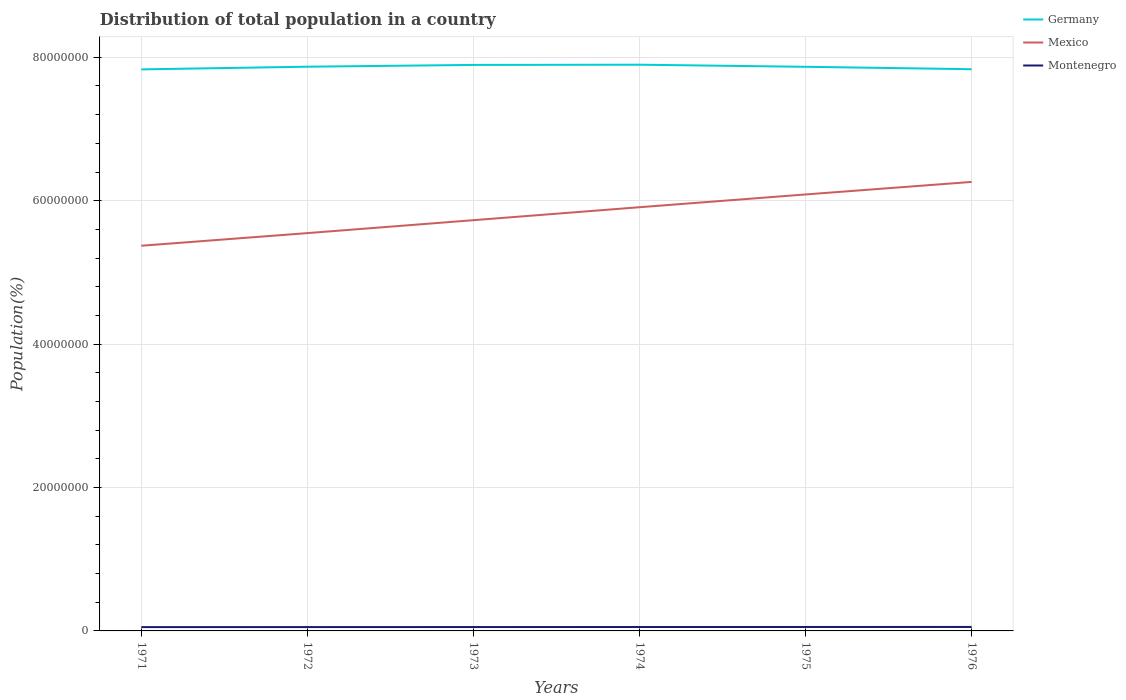How many different coloured lines are there?
Keep it short and to the point. 3. Does the line corresponding to Montenegro intersect with the line corresponding to Mexico?
Your answer should be compact. No. Is the number of lines equal to the number of legend labels?
Give a very brief answer. Yes. Across all years, what is the maximum population of in Mexico?
Offer a terse response. 5.37e+07. In which year was the population of in Germany maximum?
Keep it short and to the point. 1971. What is the total population of in Montenegro in the graph?
Give a very brief answer. -1.36e+04. What is the difference between the highest and the second highest population of in Mexico?
Your answer should be very brief. 8.90e+06. Are the values on the major ticks of Y-axis written in scientific E-notation?
Offer a very short reply. No. Where does the legend appear in the graph?
Offer a very short reply. Top right. How are the legend labels stacked?
Make the answer very short. Vertical. What is the title of the graph?
Your answer should be very brief. Distribution of total population in a country. Does "Bangladesh" appear as one of the legend labels in the graph?
Offer a very short reply. No. What is the label or title of the X-axis?
Your answer should be compact. Years. What is the label or title of the Y-axis?
Your response must be concise. Population(%). What is the Population(%) of Germany in 1971?
Offer a terse response. 7.83e+07. What is the Population(%) in Mexico in 1971?
Your answer should be compact. 5.37e+07. What is the Population(%) of Montenegro in 1971?
Offer a terse response. 5.31e+05. What is the Population(%) of Germany in 1972?
Provide a succinct answer. 7.87e+07. What is the Population(%) in Mexico in 1972?
Provide a succinct answer. 5.55e+07. What is the Population(%) in Montenegro in 1972?
Provide a short and direct response. 5.35e+05. What is the Population(%) in Germany in 1973?
Offer a very short reply. 7.89e+07. What is the Population(%) of Mexico in 1973?
Provide a short and direct response. 5.73e+07. What is the Population(%) in Montenegro in 1973?
Your answer should be compact. 5.40e+05. What is the Population(%) of Germany in 1974?
Make the answer very short. 7.90e+07. What is the Population(%) of Mexico in 1974?
Your answer should be compact. 5.91e+07. What is the Population(%) in Montenegro in 1974?
Offer a very short reply. 5.44e+05. What is the Population(%) of Germany in 1975?
Your answer should be very brief. 7.87e+07. What is the Population(%) of Mexico in 1975?
Your answer should be very brief. 6.09e+07. What is the Population(%) of Montenegro in 1975?
Provide a short and direct response. 5.49e+05. What is the Population(%) of Germany in 1976?
Keep it short and to the point. 7.83e+07. What is the Population(%) in Mexico in 1976?
Give a very brief answer. 6.26e+07. What is the Population(%) of Montenegro in 1976?
Provide a short and direct response. 5.54e+05. Across all years, what is the maximum Population(%) in Germany?
Provide a succinct answer. 7.90e+07. Across all years, what is the maximum Population(%) in Mexico?
Provide a short and direct response. 6.26e+07. Across all years, what is the maximum Population(%) in Montenegro?
Your answer should be compact. 5.54e+05. Across all years, what is the minimum Population(%) of Germany?
Make the answer very short. 7.83e+07. Across all years, what is the minimum Population(%) of Mexico?
Keep it short and to the point. 5.37e+07. Across all years, what is the minimum Population(%) of Montenegro?
Provide a succinct answer. 5.31e+05. What is the total Population(%) in Germany in the graph?
Offer a terse response. 4.72e+08. What is the total Population(%) in Mexico in the graph?
Ensure brevity in your answer.  3.49e+08. What is the total Population(%) in Montenegro in the graph?
Provide a succinct answer. 3.25e+06. What is the difference between the Population(%) of Germany in 1971 and that in 1972?
Make the answer very short. -3.76e+05. What is the difference between the Population(%) of Mexico in 1971 and that in 1972?
Keep it short and to the point. -1.76e+06. What is the difference between the Population(%) in Montenegro in 1971 and that in 1972?
Make the answer very short. -4492. What is the difference between the Population(%) of Germany in 1971 and that in 1973?
Your response must be concise. -6.24e+05. What is the difference between the Population(%) in Mexico in 1971 and that in 1973?
Offer a terse response. -3.56e+06. What is the difference between the Population(%) of Montenegro in 1971 and that in 1973?
Your answer should be compact. -8976. What is the difference between the Population(%) in Germany in 1971 and that in 1974?
Your response must be concise. -6.55e+05. What is the difference between the Population(%) in Mexico in 1971 and that in 1974?
Your answer should be very brief. -5.37e+06. What is the difference between the Population(%) of Montenegro in 1971 and that in 1974?
Offer a terse response. -1.36e+04. What is the difference between the Population(%) of Germany in 1971 and that in 1975?
Give a very brief answer. -3.61e+05. What is the difference between the Population(%) of Mexico in 1971 and that in 1975?
Provide a succinct answer. -7.15e+06. What is the difference between the Population(%) in Montenegro in 1971 and that in 1975?
Provide a short and direct response. -1.83e+04. What is the difference between the Population(%) in Germany in 1971 and that in 1976?
Ensure brevity in your answer.  -2.41e+04. What is the difference between the Population(%) in Mexico in 1971 and that in 1976?
Your response must be concise. -8.90e+06. What is the difference between the Population(%) of Montenegro in 1971 and that in 1976?
Offer a very short reply. -2.33e+04. What is the difference between the Population(%) in Germany in 1972 and that in 1973?
Provide a succinct answer. -2.48e+05. What is the difference between the Population(%) in Mexico in 1972 and that in 1973?
Provide a succinct answer. -1.80e+06. What is the difference between the Population(%) in Montenegro in 1972 and that in 1973?
Offer a very short reply. -4484. What is the difference between the Population(%) of Germany in 1972 and that in 1974?
Your answer should be very brief. -2.79e+05. What is the difference between the Population(%) in Mexico in 1972 and that in 1974?
Provide a short and direct response. -3.61e+06. What is the difference between the Population(%) in Montenegro in 1972 and that in 1974?
Make the answer very short. -9065. What is the difference between the Population(%) in Germany in 1972 and that in 1975?
Keep it short and to the point. 1.49e+04. What is the difference between the Population(%) of Mexico in 1972 and that in 1975?
Keep it short and to the point. -5.39e+06. What is the difference between the Population(%) of Montenegro in 1972 and that in 1975?
Your answer should be very brief. -1.38e+04. What is the difference between the Population(%) in Germany in 1972 and that in 1976?
Provide a short and direct response. 3.52e+05. What is the difference between the Population(%) of Mexico in 1972 and that in 1976?
Your answer should be very brief. -7.14e+06. What is the difference between the Population(%) of Montenegro in 1972 and that in 1976?
Offer a very short reply. -1.88e+04. What is the difference between the Population(%) of Germany in 1973 and that in 1974?
Keep it short and to the point. -3.08e+04. What is the difference between the Population(%) in Mexico in 1973 and that in 1974?
Make the answer very short. -1.81e+06. What is the difference between the Population(%) of Montenegro in 1973 and that in 1974?
Give a very brief answer. -4581. What is the difference between the Population(%) in Germany in 1973 and that in 1975?
Your answer should be compact. 2.63e+05. What is the difference between the Population(%) in Mexico in 1973 and that in 1975?
Your answer should be very brief. -3.59e+06. What is the difference between the Population(%) in Montenegro in 1973 and that in 1975?
Your answer should be compact. -9320. What is the difference between the Population(%) of Germany in 1973 and that in 1976?
Provide a short and direct response. 6.00e+05. What is the difference between the Population(%) in Mexico in 1973 and that in 1976?
Provide a succinct answer. -5.34e+06. What is the difference between the Population(%) of Montenegro in 1973 and that in 1976?
Your response must be concise. -1.43e+04. What is the difference between the Population(%) in Germany in 1974 and that in 1975?
Keep it short and to the point. 2.94e+05. What is the difference between the Population(%) of Mexico in 1974 and that in 1975?
Make the answer very short. -1.78e+06. What is the difference between the Population(%) of Montenegro in 1974 and that in 1975?
Your response must be concise. -4739. What is the difference between the Population(%) of Germany in 1974 and that in 1976?
Your response must be concise. 6.30e+05. What is the difference between the Population(%) of Mexico in 1974 and that in 1976?
Keep it short and to the point. -3.53e+06. What is the difference between the Population(%) in Montenegro in 1974 and that in 1976?
Provide a succinct answer. -9707. What is the difference between the Population(%) of Germany in 1975 and that in 1976?
Your response must be concise. 3.37e+05. What is the difference between the Population(%) of Mexico in 1975 and that in 1976?
Your answer should be compact. -1.75e+06. What is the difference between the Population(%) in Montenegro in 1975 and that in 1976?
Your answer should be compact. -4968. What is the difference between the Population(%) of Germany in 1971 and the Population(%) of Mexico in 1972?
Provide a short and direct response. 2.28e+07. What is the difference between the Population(%) in Germany in 1971 and the Population(%) in Montenegro in 1972?
Keep it short and to the point. 7.78e+07. What is the difference between the Population(%) in Mexico in 1971 and the Population(%) in Montenegro in 1972?
Give a very brief answer. 5.32e+07. What is the difference between the Population(%) of Germany in 1971 and the Population(%) of Mexico in 1973?
Make the answer very short. 2.10e+07. What is the difference between the Population(%) of Germany in 1971 and the Population(%) of Montenegro in 1973?
Make the answer very short. 7.78e+07. What is the difference between the Population(%) in Mexico in 1971 and the Population(%) in Montenegro in 1973?
Keep it short and to the point. 5.32e+07. What is the difference between the Population(%) of Germany in 1971 and the Population(%) of Mexico in 1974?
Make the answer very short. 1.92e+07. What is the difference between the Population(%) of Germany in 1971 and the Population(%) of Montenegro in 1974?
Offer a very short reply. 7.78e+07. What is the difference between the Population(%) in Mexico in 1971 and the Population(%) in Montenegro in 1974?
Your answer should be very brief. 5.32e+07. What is the difference between the Population(%) in Germany in 1971 and the Population(%) in Mexico in 1975?
Provide a succinct answer. 1.74e+07. What is the difference between the Population(%) in Germany in 1971 and the Population(%) in Montenegro in 1975?
Offer a terse response. 7.78e+07. What is the difference between the Population(%) of Mexico in 1971 and the Population(%) of Montenegro in 1975?
Offer a very short reply. 5.32e+07. What is the difference between the Population(%) of Germany in 1971 and the Population(%) of Mexico in 1976?
Your response must be concise. 1.57e+07. What is the difference between the Population(%) of Germany in 1971 and the Population(%) of Montenegro in 1976?
Make the answer very short. 7.78e+07. What is the difference between the Population(%) in Mexico in 1971 and the Population(%) in Montenegro in 1976?
Give a very brief answer. 5.32e+07. What is the difference between the Population(%) in Germany in 1972 and the Population(%) in Mexico in 1973?
Provide a succinct answer. 2.14e+07. What is the difference between the Population(%) in Germany in 1972 and the Population(%) in Montenegro in 1973?
Make the answer very short. 7.81e+07. What is the difference between the Population(%) of Mexico in 1972 and the Population(%) of Montenegro in 1973?
Offer a terse response. 5.49e+07. What is the difference between the Population(%) of Germany in 1972 and the Population(%) of Mexico in 1974?
Provide a succinct answer. 1.96e+07. What is the difference between the Population(%) of Germany in 1972 and the Population(%) of Montenegro in 1974?
Your answer should be compact. 7.81e+07. What is the difference between the Population(%) in Mexico in 1972 and the Population(%) in Montenegro in 1974?
Offer a very short reply. 5.49e+07. What is the difference between the Population(%) in Germany in 1972 and the Population(%) in Mexico in 1975?
Give a very brief answer. 1.78e+07. What is the difference between the Population(%) in Germany in 1972 and the Population(%) in Montenegro in 1975?
Your response must be concise. 7.81e+07. What is the difference between the Population(%) in Mexico in 1972 and the Population(%) in Montenegro in 1975?
Your response must be concise. 5.49e+07. What is the difference between the Population(%) in Germany in 1972 and the Population(%) in Mexico in 1976?
Offer a terse response. 1.61e+07. What is the difference between the Population(%) in Germany in 1972 and the Population(%) in Montenegro in 1976?
Ensure brevity in your answer.  7.81e+07. What is the difference between the Population(%) of Mexico in 1972 and the Population(%) of Montenegro in 1976?
Your response must be concise. 5.49e+07. What is the difference between the Population(%) of Germany in 1973 and the Population(%) of Mexico in 1974?
Offer a terse response. 1.98e+07. What is the difference between the Population(%) of Germany in 1973 and the Population(%) of Montenegro in 1974?
Keep it short and to the point. 7.84e+07. What is the difference between the Population(%) in Mexico in 1973 and the Population(%) in Montenegro in 1974?
Keep it short and to the point. 5.67e+07. What is the difference between the Population(%) in Germany in 1973 and the Population(%) in Mexico in 1975?
Offer a very short reply. 1.81e+07. What is the difference between the Population(%) in Germany in 1973 and the Population(%) in Montenegro in 1975?
Keep it short and to the point. 7.84e+07. What is the difference between the Population(%) of Mexico in 1973 and the Population(%) of Montenegro in 1975?
Make the answer very short. 5.67e+07. What is the difference between the Population(%) in Germany in 1973 and the Population(%) in Mexico in 1976?
Make the answer very short. 1.63e+07. What is the difference between the Population(%) in Germany in 1973 and the Population(%) in Montenegro in 1976?
Ensure brevity in your answer.  7.84e+07. What is the difference between the Population(%) in Mexico in 1973 and the Population(%) in Montenegro in 1976?
Provide a succinct answer. 5.67e+07. What is the difference between the Population(%) in Germany in 1974 and the Population(%) in Mexico in 1975?
Make the answer very short. 1.81e+07. What is the difference between the Population(%) in Germany in 1974 and the Population(%) in Montenegro in 1975?
Your answer should be very brief. 7.84e+07. What is the difference between the Population(%) in Mexico in 1974 and the Population(%) in Montenegro in 1975?
Give a very brief answer. 5.85e+07. What is the difference between the Population(%) in Germany in 1974 and the Population(%) in Mexico in 1976?
Your answer should be very brief. 1.63e+07. What is the difference between the Population(%) in Germany in 1974 and the Population(%) in Montenegro in 1976?
Give a very brief answer. 7.84e+07. What is the difference between the Population(%) of Mexico in 1974 and the Population(%) of Montenegro in 1976?
Offer a terse response. 5.85e+07. What is the difference between the Population(%) in Germany in 1975 and the Population(%) in Mexico in 1976?
Keep it short and to the point. 1.61e+07. What is the difference between the Population(%) in Germany in 1975 and the Population(%) in Montenegro in 1976?
Your answer should be compact. 7.81e+07. What is the difference between the Population(%) in Mexico in 1975 and the Population(%) in Montenegro in 1976?
Offer a terse response. 6.03e+07. What is the average Population(%) in Germany per year?
Provide a succinct answer. 7.87e+07. What is the average Population(%) in Mexico per year?
Provide a short and direct response. 5.82e+07. What is the average Population(%) in Montenegro per year?
Provide a short and direct response. 5.42e+05. In the year 1971, what is the difference between the Population(%) of Germany and Population(%) of Mexico?
Provide a succinct answer. 2.46e+07. In the year 1971, what is the difference between the Population(%) in Germany and Population(%) in Montenegro?
Give a very brief answer. 7.78e+07. In the year 1971, what is the difference between the Population(%) of Mexico and Population(%) of Montenegro?
Keep it short and to the point. 5.32e+07. In the year 1972, what is the difference between the Population(%) in Germany and Population(%) in Mexico?
Your response must be concise. 2.32e+07. In the year 1972, what is the difference between the Population(%) in Germany and Population(%) in Montenegro?
Your response must be concise. 7.82e+07. In the year 1972, what is the difference between the Population(%) in Mexico and Population(%) in Montenegro?
Your response must be concise. 5.49e+07. In the year 1973, what is the difference between the Population(%) of Germany and Population(%) of Mexico?
Your answer should be very brief. 2.17e+07. In the year 1973, what is the difference between the Population(%) of Germany and Population(%) of Montenegro?
Your response must be concise. 7.84e+07. In the year 1973, what is the difference between the Population(%) in Mexico and Population(%) in Montenegro?
Your answer should be very brief. 5.67e+07. In the year 1974, what is the difference between the Population(%) in Germany and Population(%) in Mexico?
Give a very brief answer. 1.99e+07. In the year 1974, what is the difference between the Population(%) of Germany and Population(%) of Montenegro?
Your answer should be compact. 7.84e+07. In the year 1974, what is the difference between the Population(%) in Mexico and Population(%) in Montenegro?
Ensure brevity in your answer.  5.85e+07. In the year 1975, what is the difference between the Population(%) in Germany and Population(%) in Mexico?
Offer a very short reply. 1.78e+07. In the year 1975, what is the difference between the Population(%) in Germany and Population(%) in Montenegro?
Give a very brief answer. 7.81e+07. In the year 1975, what is the difference between the Population(%) in Mexico and Population(%) in Montenegro?
Your answer should be compact. 6.03e+07. In the year 1976, what is the difference between the Population(%) of Germany and Population(%) of Mexico?
Make the answer very short. 1.57e+07. In the year 1976, what is the difference between the Population(%) in Germany and Population(%) in Montenegro?
Make the answer very short. 7.78e+07. In the year 1976, what is the difference between the Population(%) of Mexico and Population(%) of Montenegro?
Your answer should be very brief. 6.21e+07. What is the ratio of the Population(%) of Mexico in 1971 to that in 1972?
Offer a terse response. 0.97. What is the ratio of the Population(%) in Mexico in 1971 to that in 1973?
Provide a short and direct response. 0.94. What is the ratio of the Population(%) in Montenegro in 1971 to that in 1973?
Your response must be concise. 0.98. What is the ratio of the Population(%) of Germany in 1971 to that in 1974?
Provide a succinct answer. 0.99. What is the ratio of the Population(%) of Montenegro in 1971 to that in 1974?
Offer a terse response. 0.98. What is the ratio of the Population(%) of Germany in 1971 to that in 1975?
Your answer should be compact. 1. What is the ratio of the Population(%) of Mexico in 1971 to that in 1975?
Give a very brief answer. 0.88. What is the ratio of the Population(%) of Montenegro in 1971 to that in 1975?
Ensure brevity in your answer.  0.97. What is the ratio of the Population(%) in Germany in 1971 to that in 1976?
Offer a terse response. 1. What is the ratio of the Population(%) of Mexico in 1971 to that in 1976?
Provide a short and direct response. 0.86. What is the ratio of the Population(%) of Montenegro in 1971 to that in 1976?
Offer a very short reply. 0.96. What is the ratio of the Population(%) in Germany in 1972 to that in 1973?
Provide a succinct answer. 1. What is the ratio of the Population(%) in Mexico in 1972 to that in 1973?
Offer a very short reply. 0.97. What is the ratio of the Population(%) of Mexico in 1972 to that in 1974?
Give a very brief answer. 0.94. What is the ratio of the Population(%) of Montenegro in 1972 to that in 1974?
Offer a very short reply. 0.98. What is the ratio of the Population(%) in Germany in 1972 to that in 1975?
Give a very brief answer. 1. What is the ratio of the Population(%) in Mexico in 1972 to that in 1975?
Your answer should be compact. 0.91. What is the ratio of the Population(%) in Montenegro in 1972 to that in 1975?
Offer a very short reply. 0.97. What is the ratio of the Population(%) of Mexico in 1972 to that in 1976?
Your response must be concise. 0.89. What is the ratio of the Population(%) of Montenegro in 1972 to that in 1976?
Offer a terse response. 0.97. What is the ratio of the Population(%) in Mexico in 1973 to that in 1974?
Give a very brief answer. 0.97. What is the ratio of the Population(%) of Montenegro in 1973 to that in 1974?
Your answer should be compact. 0.99. What is the ratio of the Population(%) in Mexico in 1973 to that in 1975?
Make the answer very short. 0.94. What is the ratio of the Population(%) of Germany in 1973 to that in 1976?
Make the answer very short. 1.01. What is the ratio of the Population(%) of Mexico in 1973 to that in 1976?
Provide a succinct answer. 0.91. What is the ratio of the Population(%) in Montenegro in 1973 to that in 1976?
Make the answer very short. 0.97. What is the ratio of the Population(%) in Germany in 1974 to that in 1975?
Your answer should be compact. 1. What is the ratio of the Population(%) in Mexico in 1974 to that in 1975?
Make the answer very short. 0.97. What is the ratio of the Population(%) in Germany in 1974 to that in 1976?
Offer a very short reply. 1.01. What is the ratio of the Population(%) of Mexico in 1974 to that in 1976?
Your answer should be very brief. 0.94. What is the ratio of the Population(%) of Montenegro in 1974 to that in 1976?
Your response must be concise. 0.98. What is the ratio of the Population(%) of Mexico in 1975 to that in 1976?
Offer a very short reply. 0.97. What is the difference between the highest and the second highest Population(%) of Germany?
Offer a very short reply. 3.08e+04. What is the difference between the highest and the second highest Population(%) in Mexico?
Ensure brevity in your answer.  1.75e+06. What is the difference between the highest and the second highest Population(%) in Montenegro?
Provide a short and direct response. 4968. What is the difference between the highest and the lowest Population(%) of Germany?
Ensure brevity in your answer.  6.55e+05. What is the difference between the highest and the lowest Population(%) of Mexico?
Your answer should be very brief. 8.90e+06. What is the difference between the highest and the lowest Population(%) in Montenegro?
Keep it short and to the point. 2.33e+04. 